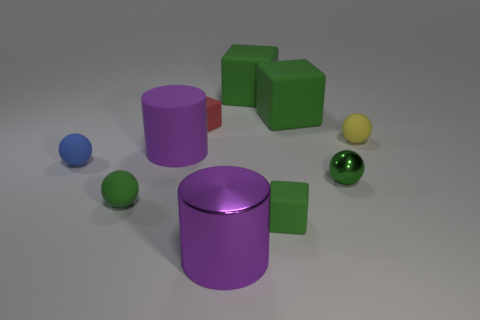What number of green spheres are the same size as the red cube?
Keep it short and to the point. 2. There is a green cube that is in front of the yellow matte object; is it the same size as the purple rubber cylinder on the left side of the yellow ball?
Offer a terse response. No. What shape is the purple thing that is to the left of the red object?
Provide a short and direct response. Cylinder. What is the green block in front of the large object left of the red cube made of?
Keep it short and to the point. Rubber. Is there a big matte object that has the same color as the large metallic object?
Offer a very short reply. Yes. There is a green metal object; does it have the same size as the green ball that is in front of the small metal thing?
Provide a succinct answer. Yes. There is a green matte block that is on the left side of the tiny matte cube that is in front of the small red matte thing; how many red matte things are in front of it?
Ensure brevity in your answer.  1. There is a small red cube; what number of red cubes are in front of it?
Ensure brevity in your answer.  0. What color is the metal object in front of the rubber cube in front of the yellow sphere?
Your response must be concise. Purple. How many other objects are the same material as the yellow sphere?
Provide a short and direct response. 7. 